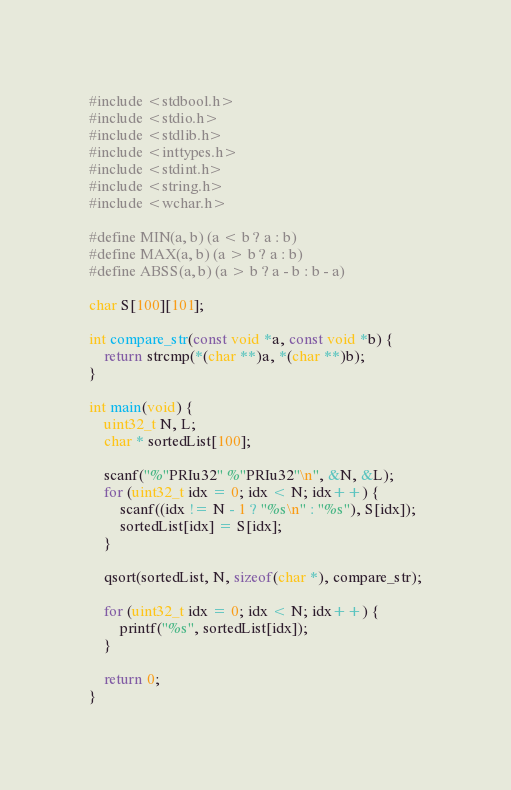<code> <loc_0><loc_0><loc_500><loc_500><_C_>#include <stdbool.h>
#include <stdio.h>
#include <stdlib.h>
#include <inttypes.h>
#include <stdint.h>
#include <string.h>
#include <wchar.h>

#define MIN(a, b) (a < b ? a : b)
#define MAX(a, b) (a > b ? a : b)
#define ABSS(a, b) (a > b ? a - b : b - a)

char S[100][101];

int compare_str(const void *a, const void *b) {
	return strcmp(*(char **)a, *(char **)b);
}

int main(void) {
	uint32_t N, L;
	char * sortedList[100];

	scanf("%"PRIu32" %"PRIu32"\n", &N, &L);
	for (uint32_t idx = 0; idx < N; idx++) {
		scanf((idx != N - 1 ? "%s\n" : "%s"), S[idx]);
		sortedList[idx] = S[idx];
	}

	qsort(sortedList, N, sizeof(char *), compare_str);

	for (uint32_t idx = 0; idx < N; idx++) {
		printf("%s", sortedList[idx]);
	}

	return 0;
}
</code> 